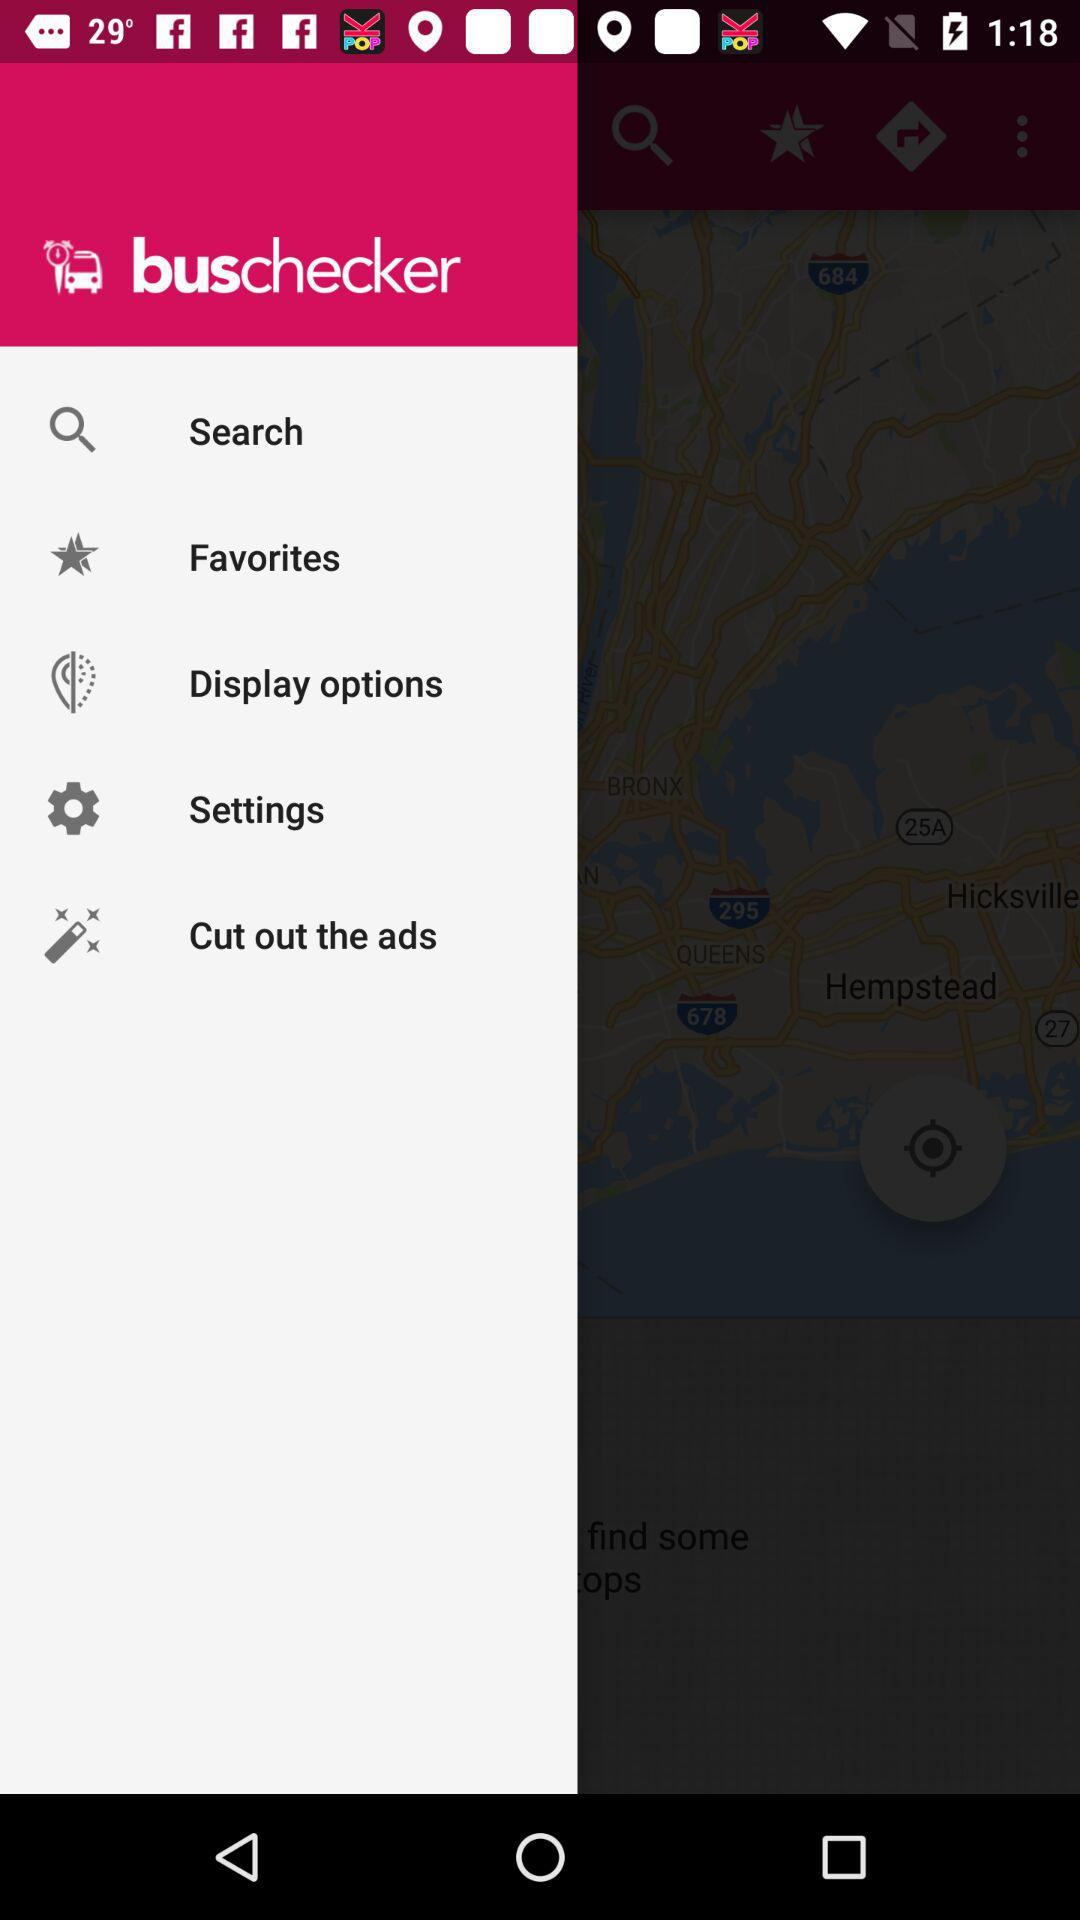What is the application Name? The application name is "buschecker". 